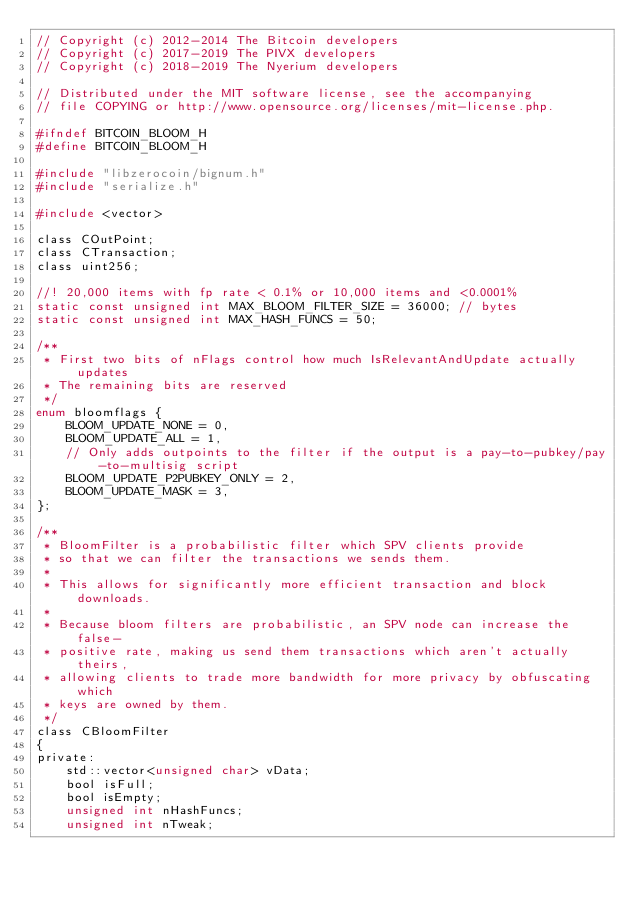<code> <loc_0><loc_0><loc_500><loc_500><_C_>// Copyright (c) 2012-2014 The Bitcoin developers
// Copyright (c) 2017-2019 The PIVX developers
// Copyright (c) 2018-2019 The Nyerium developers

// Distributed under the MIT software license, see the accompanying
// file COPYING or http://www.opensource.org/licenses/mit-license.php.

#ifndef BITCOIN_BLOOM_H
#define BITCOIN_BLOOM_H

#include "libzerocoin/bignum.h"
#include "serialize.h"

#include <vector>

class COutPoint;
class CTransaction;
class uint256;

//! 20,000 items with fp rate < 0.1% or 10,000 items and <0.0001%
static const unsigned int MAX_BLOOM_FILTER_SIZE = 36000; // bytes
static const unsigned int MAX_HASH_FUNCS = 50;

/**
 * First two bits of nFlags control how much IsRelevantAndUpdate actually updates
 * The remaining bits are reserved
 */
enum bloomflags {
    BLOOM_UPDATE_NONE = 0,
    BLOOM_UPDATE_ALL = 1,
    // Only adds outpoints to the filter if the output is a pay-to-pubkey/pay-to-multisig script
    BLOOM_UPDATE_P2PUBKEY_ONLY = 2,
    BLOOM_UPDATE_MASK = 3,
};

/**
 * BloomFilter is a probabilistic filter which SPV clients provide
 * so that we can filter the transactions we sends them.
 * 
 * This allows for significantly more efficient transaction and block downloads.
 * 
 * Because bloom filters are probabilistic, an SPV node can increase the false-
 * positive rate, making us send them transactions which aren't actually theirs, 
 * allowing clients to trade more bandwidth for more privacy by obfuscating which
 * keys are owned by them.
 */
class CBloomFilter
{
private:
    std::vector<unsigned char> vData;
    bool isFull;
    bool isEmpty;
    unsigned int nHashFuncs;
    unsigned int nTweak;</code> 